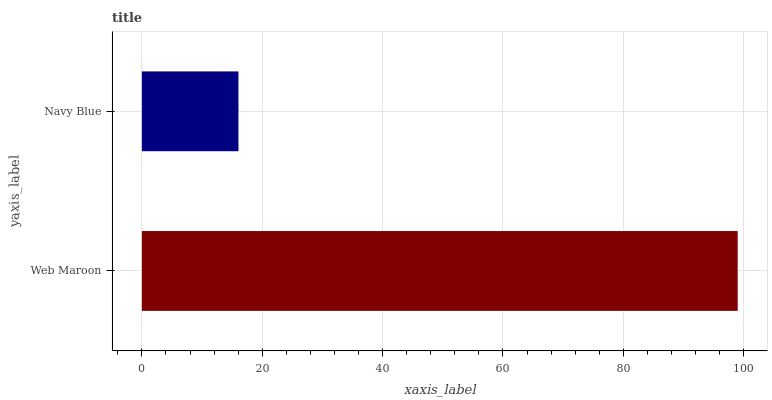Is Navy Blue the minimum?
Answer yes or no. Yes. Is Web Maroon the maximum?
Answer yes or no. Yes. Is Navy Blue the maximum?
Answer yes or no. No. Is Web Maroon greater than Navy Blue?
Answer yes or no. Yes. Is Navy Blue less than Web Maroon?
Answer yes or no. Yes. Is Navy Blue greater than Web Maroon?
Answer yes or no. No. Is Web Maroon less than Navy Blue?
Answer yes or no. No. Is Web Maroon the high median?
Answer yes or no. Yes. Is Navy Blue the low median?
Answer yes or no. Yes. Is Navy Blue the high median?
Answer yes or no. No. Is Web Maroon the low median?
Answer yes or no. No. 